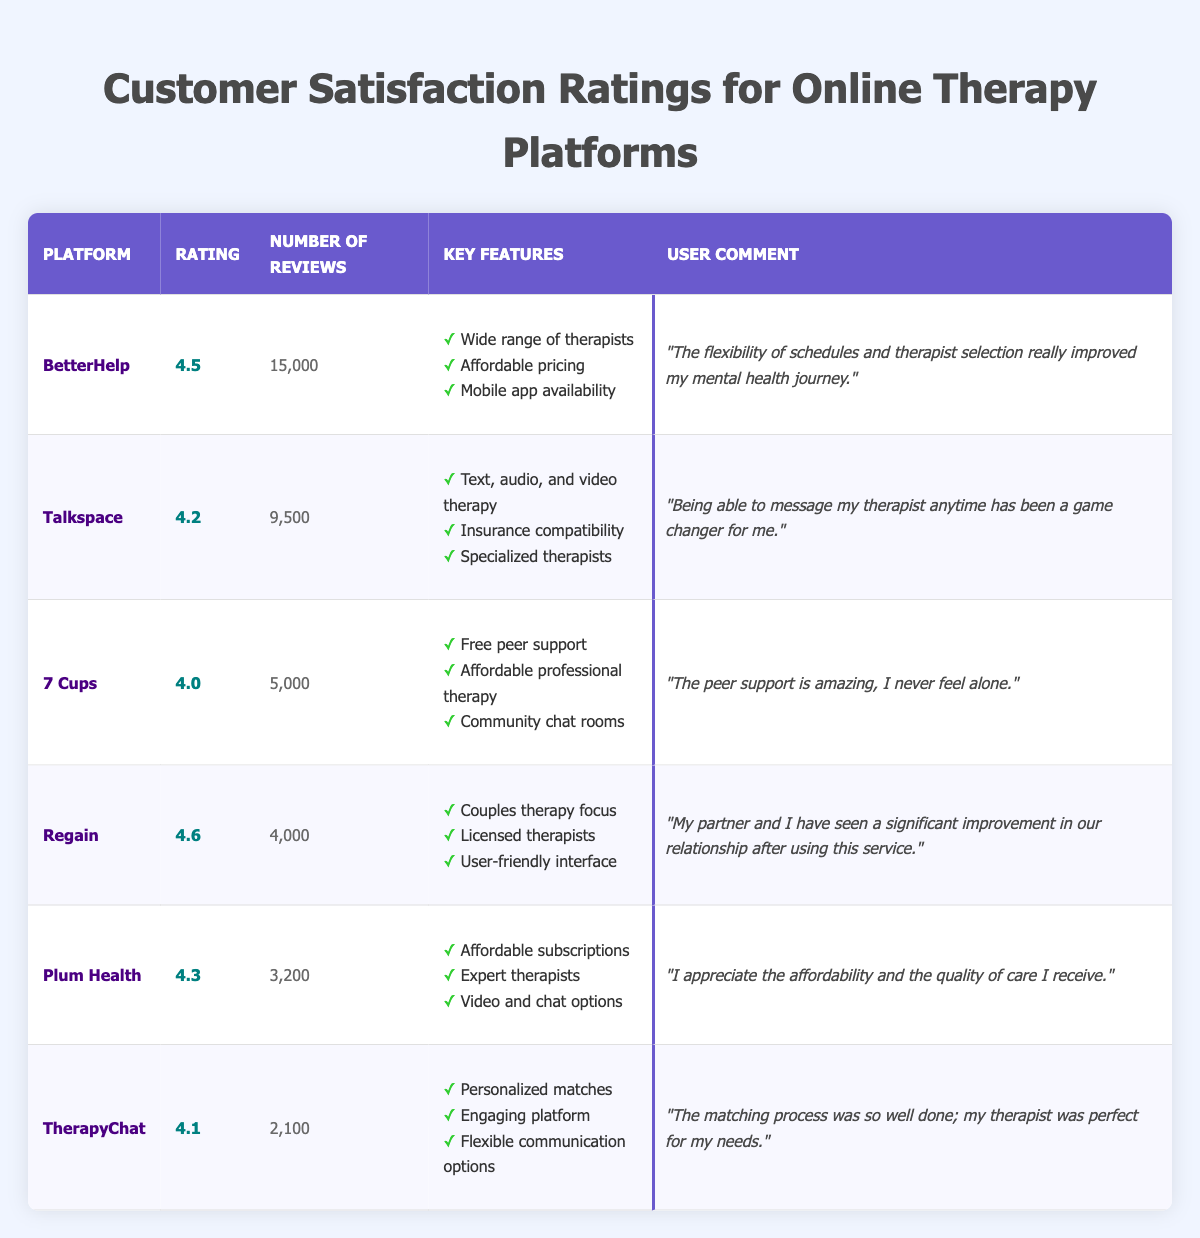What is the highest customer satisfaction rating among the platforms? By reviewing the "Rating" column in the table, I can see that "Regain" has the highest rating of 4.6.
Answer: 4.6 Which platform has the most customer reviews? Looking at the "Number of Reviews" column, "BetterHelp" has the highest number of reviews, with 15,000.
Answer: BetterHelp How many total reviews are there across all platforms? Summing the reviews: 15,000 (BetterHelp) + 9,500 (Talkspace) + 5,000 (7 Cups) + 4,000 (Regain) + 3,200 (Plum Health) + 2,100 (TherapyChat) equals 38,800 in total.
Answer: 38,800 What is the average customer satisfaction rating for the platforms listed? Calculate the average by adding all ratings (4.5 + 4.2 + 4.0 + 4.6 + 4.3 + 4.1 = 25.7) and dividing by the number of platforms (6), resulting in an average of approximately 4.28.
Answer: 4.28 Does "Talkspace" have a higher rating than "7 Cups"? Checking both ratings: "Talkspace" has a rating of 4.2, while "7 Cups" has a rating of 4.0. Since 4.2 is greater than 4.0, the statement is true.
Answer: Yes Which platform specializes in couples therapy? The "Key Features" of "Regain" specifically mention a "Couples therapy focus," indicating this platform specializes in that area.
Answer: Regain What is the difference between the highest and lowest ratings? The highest rating is 4.6 (Regain), and the lowest rating is 4.0 (7 Cups). The difference is 4.6 - 4.0 = 0.6.
Answer: 0.6 Which platform has the least number of reviews, and what is that number? "TherapyChat" has the least reviews listed at 2,100, making it the platform with the lowest number of reviews.
Answer: 2,100 What percentage of reviews does "Regain" have compared to the total reviews? To find the percentage, divide the reviews for Regain (4,000) by total reviews (38,800) and multiply by 100: (4,000/38,800) * 100 ≈ 10.3%.
Answer: 10.3% Is there any platform with a rating of exactly 4.4? Checking the ratings, there are no platforms listed with a rating of 4.4; those are either above or below this number, confirming the statement is true.
Answer: No 